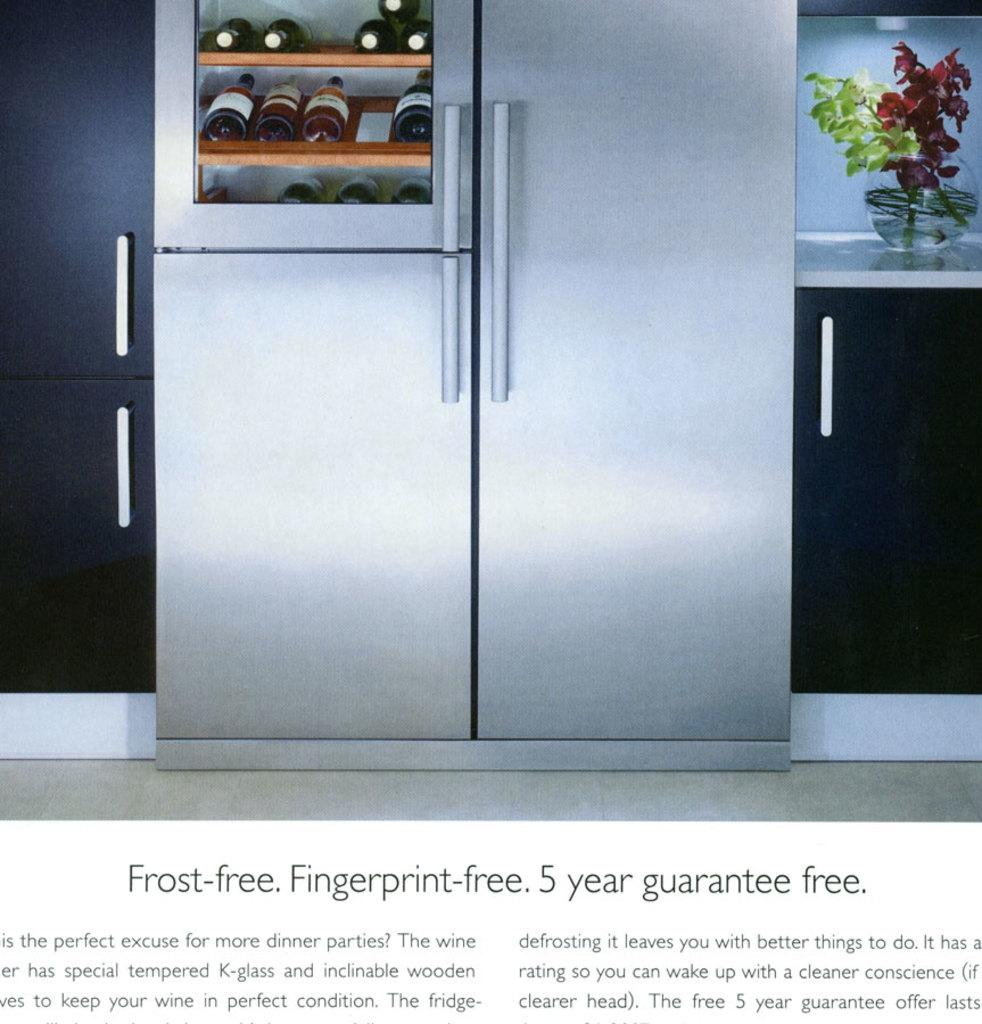<image>
Render a clear and concise summary of the photo. An advertisement for a fingerprint free fridge with a 5 year guarantee 